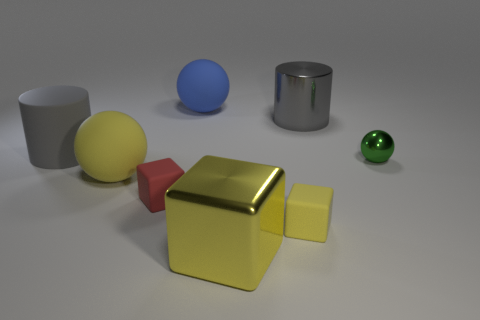How many spheres are metallic things or blue objects?
Offer a very short reply. 2. What number of tiny things are both left of the big blue sphere and behind the tiny red object?
Your answer should be compact. 0. Is the number of gray shiny cylinders on the left side of the yellow matte cube the same as the number of tiny yellow matte blocks to the right of the green thing?
Your response must be concise. Yes. Do the metallic object that is in front of the tiny green metal ball and the green thing have the same shape?
Keep it short and to the point. No. What shape is the object that is on the right side of the big gray cylinder behind the gray rubber object that is left of the small red cube?
Keep it short and to the point. Sphere. There is a large matte thing that is the same color as the big cube; what shape is it?
Keep it short and to the point. Sphere. What material is the ball that is both right of the red block and left of the big yellow metal cube?
Provide a short and direct response. Rubber. Are there fewer matte cylinders than gray cylinders?
Offer a very short reply. Yes. Do the green metal thing and the big yellow object behind the red matte cube have the same shape?
Offer a terse response. Yes. Do the metal thing that is behind the green shiny sphere and the green metallic object have the same size?
Provide a short and direct response. No. 